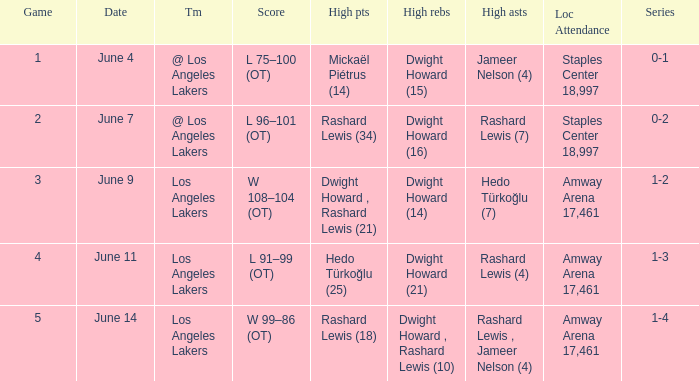What is High Assists, when High Rebounds is "Dwight Howard , Rashard Lewis (10)"? Rashard Lewis , Jameer Nelson (4). Could you help me parse every detail presented in this table? {'header': ['Game', 'Date', 'Tm', 'Score', 'High pts', 'High rebs', 'High asts', 'Loc Attendance', 'Series'], 'rows': [['1', 'June 4', '@ Los Angeles Lakers', 'L 75–100 (OT)', 'Mickaël Piétrus (14)', 'Dwight Howard (15)', 'Jameer Nelson (4)', 'Staples Center 18,997', '0-1'], ['2', 'June 7', '@ Los Angeles Lakers', 'L 96–101 (OT)', 'Rashard Lewis (34)', 'Dwight Howard (16)', 'Rashard Lewis (7)', 'Staples Center 18,997', '0-2'], ['3', 'June 9', 'Los Angeles Lakers', 'W 108–104 (OT)', 'Dwight Howard , Rashard Lewis (21)', 'Dwight Howard (14)', 'Hedo Türkoğlu (7)', 'Amway Arena 17,461', '1-2'], ['4', 'June 11', 'Los Angeles Lakers', 'L 91–99 (OT)', 'Hedo Türkoğlu (25)', 'Dwight Howard (21)', 'Rashard Lewis (4)', 'Amway Arena 17,461', '1-3'], ['5', 'June 14', 'Los Angeles Lakers', 'W 99–86 (OT)', 'Rashard Lewis (18)', 'Dwight Howard , Rashard Lewis (10)', 'Rashard Lewis , Jameer Nelson (4)', 'Amway Arena 17,461', '1-4']]} 